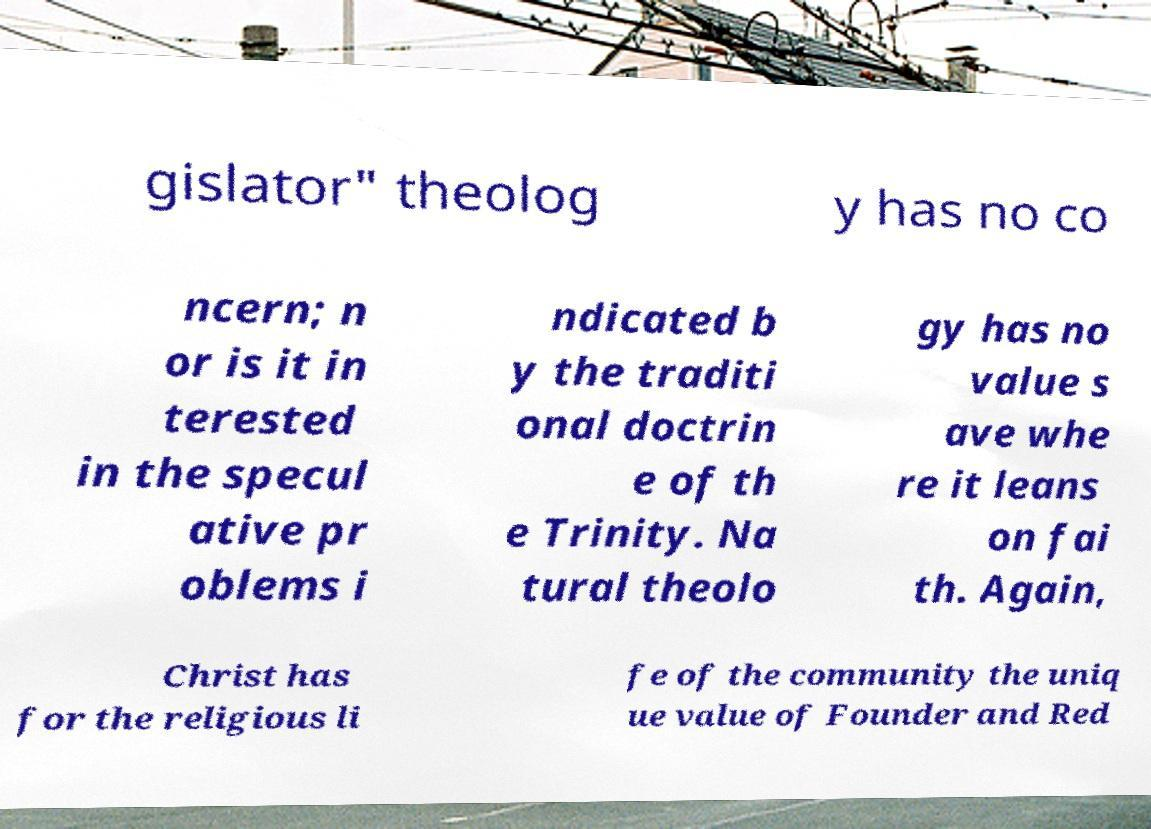What messages or text are displayed in this image? I need them in a readable, typed format. gislator" theolog y has no co ncern; n or is it in terested in the specul ative pr oblems i ndicated b y the traditi onal doctrin e of th e Trinity. Na tural theolo gy has no value s ave whe re it leans on fai th. Again, Christ has for the religious li fe of the community the uniq ue value of Founder and Red 